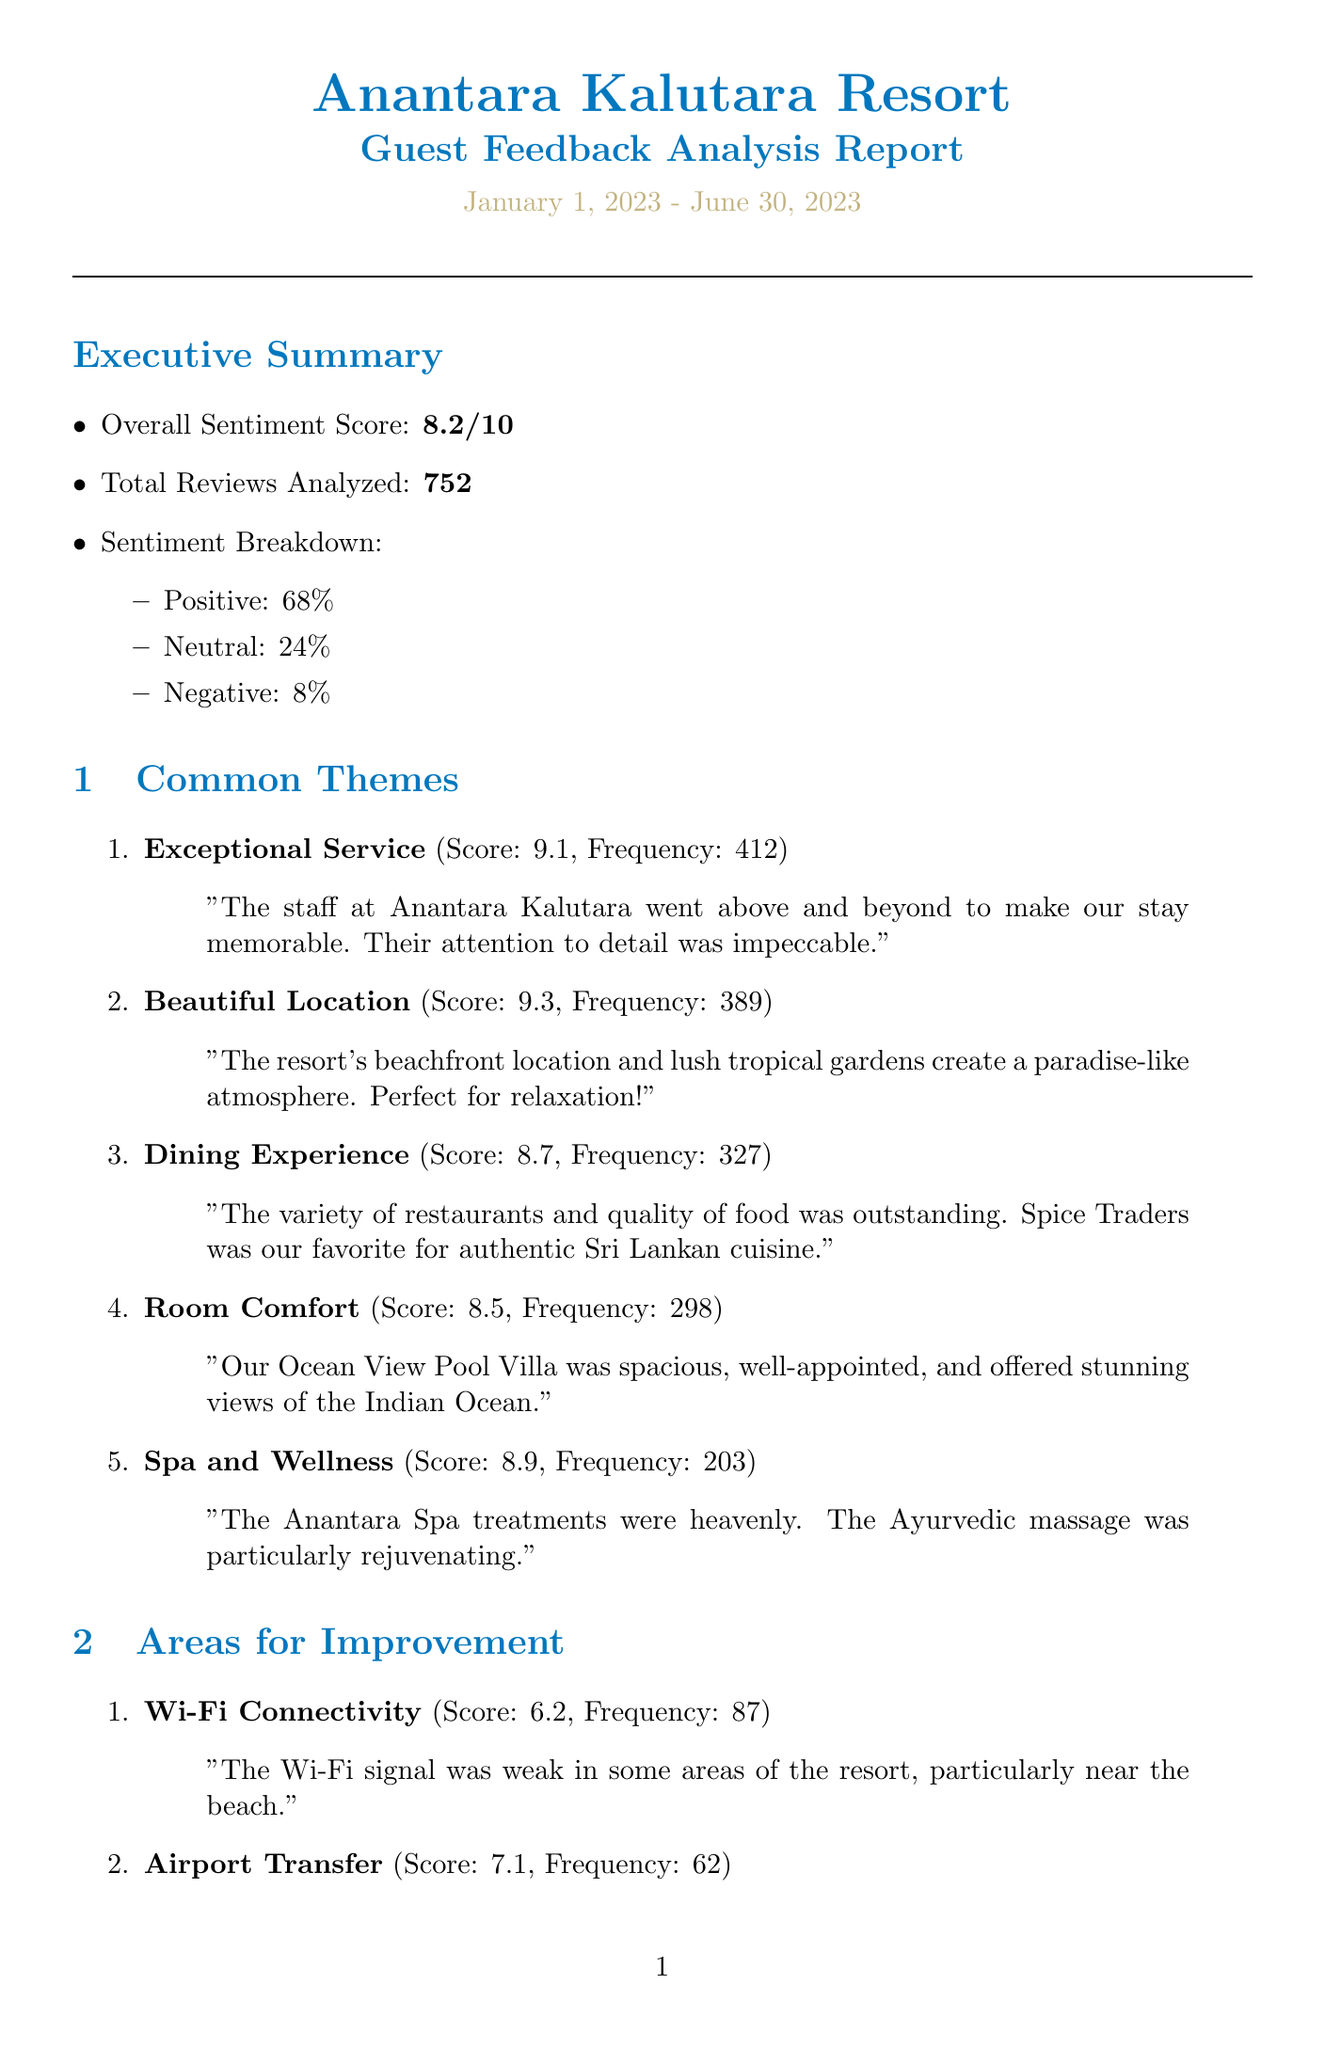What is the overall sentiment score? The overall sentiment score is a measure of guest satisfaction calculated from the reviews analyzed.
Answer: 8.2 How many total reviews were analyzed? The total reviews analyzed indicates the number of guest feedback assessed in the report.
Answer: 752 What is the sentiment score for Exceptional Service? The sentiment score for Exceptional Service reflects the guests' satisfaction based on their comments about service.
Answer: 9.1 What area received the lowest sentiment score? The area that received the lowest sentiment score highlights the aspect of the resort that needs improvement based on guest feedback.
Answer: Wi-Fi Connectivity What is the estimated cost to enhance the Wi-Fi infrastructure? The estimated cost to enhance the Wi-Fi infrastructure is the financial investment needed to implement the suggested improvements.
Answer: $25,000 Which competitor has a sentiment score of 8.4? A competitor's sentiment score provides a benchmark for comparison with Anantara Kalutara Resort's performance in guest satisfaction.
Answer: Amangalla What unique selling point focuses on wellness? The unique selling points describe what makes the resort special and what competitive advantages it has in the marketplace.
Answer: Luxurious Anantara Spa with Ayurvedic treatments How frequently was the theme of Beautiful Location mentioned? The frequency indicates how often a particular theme was highlighted in guest reviews, emphasizing its importance to guest experience.
Answer: 389 What is the potential impact of streamlining the airport transfer process? The potential impact describes the expected outcome or benefits of implementing the suggested improvements in the report.
Answer: Reduced transfer-related complaints and enhanced first impressions 